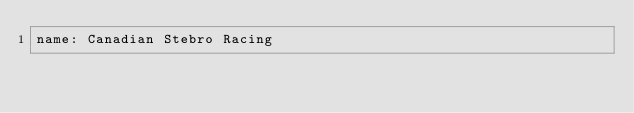Convert code to text. <code><loc_0><loc_0><loc_500><loc_500><_YAML_>name: Canadian Stebro Racing
</code> 